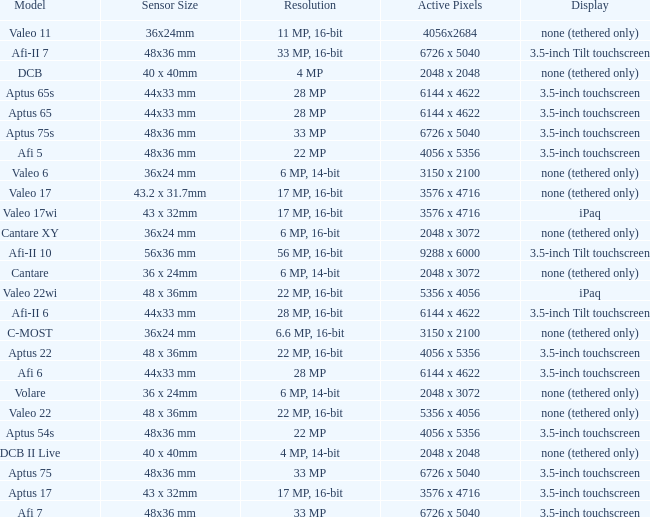What is the resolution of the camera that has 6726 x 5040 pixels and a model of afi 7? 33 MP. 